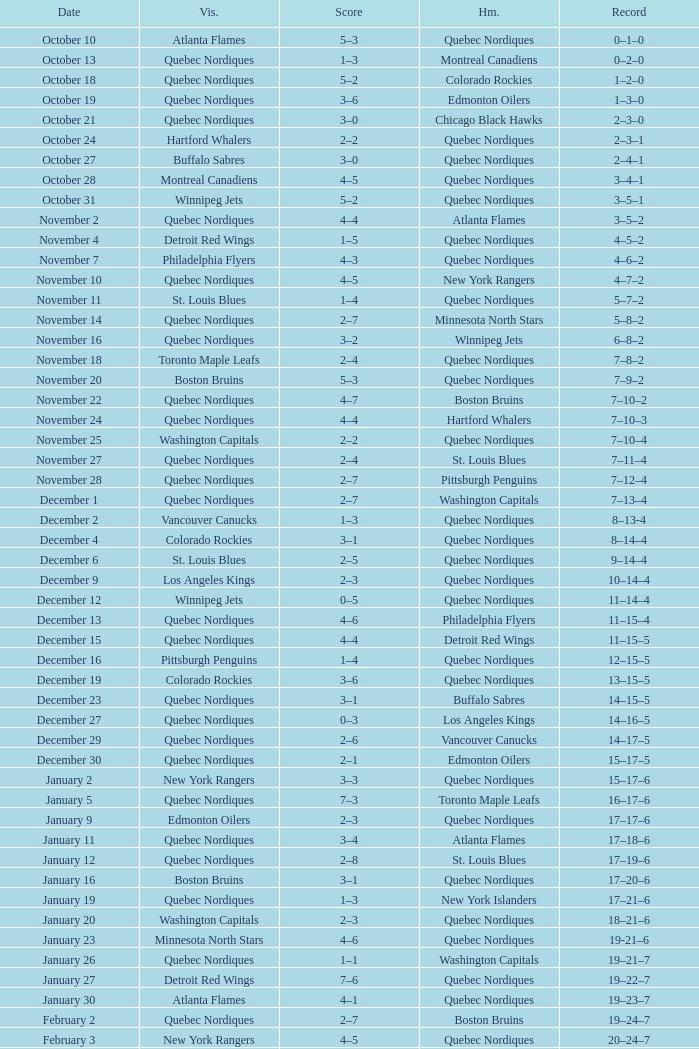Would you mind parsing the complete table? {'header': ['Date', 'Vis.', 'Score', 'Hm.', 'Record'], 'rows': [['October 10', 'Atlanta Flames', '5–3', 'Quebec Nordiques', '0–1–0'], ['October 13', 'Quebec Nordiques', '1–3', 'Montreal Canadiens', '0–2–0'], ['October 18', 'Quebec Nordiques', '5–2', 'Colorado Rockies', '1–2–0'], ['October 19', 'Quebec Nordiques', '3–6', 'Edmonton Oilers', '1–3–0'], ['October 21', 'Quebec Nordiques', '3–0', 'Chicago Black Hawks', '2–3–0'], ['October 24', 'Hartford Whalers', '2–2', 'Quebec Nordiques', '2–3–1'], ['October 27', 'Buffalo Sabres', '3–0', 'Quebec Nordiques', '2–4–1'], ['October 28', 'Montreal Canadiens', '4–5', 'Quebec Nordiques', '3–4–1'], ['October 31', 'Winnipeg Jets', '5–2', 'Quebec Nordiques', '3–5–1'], ['November 2', 'Quebec Nordiques', '4–4', 'Atlanta Flames', '3–5–2'], ['November 4', 'Detroit Red Wings', '1–5', 'Quebec Nordiques', '4–5–2'], ['November 7', 'Philadelphia Flyers', '4–3', 'Quebec Nordiques', '4–6–2'], ['November 10', 'Quebec Nordiques', '4–5', 'New York Rangers', '4–7–2'], ['November 11', 'St. Louis Blues', '1–4', 'Quebec Nordiques', '5–7–2'], ['November 14', 'Quebec Nordiques', '2–7', 'Minnesota North Stars', '5–8–2'], ['November 16', 'Quebec Nordiques', '3–2', 'Winnipeg Jets', '6–8–2'], ['November 18', 'Toronto Maple Leafs', '2–4', 'Quebec Nordiques', '7–8–2'], ['November 20', 'Boston Bruins', '5–3', 'Quebec Nordiques', '7–9–2'], ['November 22', 'Quebec Nordiques', '4–7', 'Boston Bruins', '7–10–2'], ['November 24', 'Quebec Nordiques', '4–4', 'Hartford Whalers', '7–10–3'], ['November 25', 'Washington Capitals', '2–2', 'Quebec Nordiques', '7–10–4'], ['November 27', 'Quebec Nordiques', '2–4', 'St. Louis Blues', '7–11–4'], ['November 28', 'Quebec Nordiques', '2–7', 'Pittsburgh Penguins', '7–12–4'], ['December 1', 'Quebec Nordiques', '2–7', 'Washington Capitals', '7–13–4'], ['December 2', 'Vancouver Canucks', '1–3', 'Quebec Nordiques', '8–13-4'], ['December 4', 'Colorado Rockies', '3–1', 'Quebec Nordiques', '8–14–4'], ['December 6', 'St. Louis Blues', '2–5', 'Quebec Nordiques', '9–14–4'], ['December 9', 'Los Angeles Kings', '2–3', 'Quebec Nordiques', '10–14–4'], ['December 12', 'Winnipeg Jets', '0–5', 'Quebec Nordiques', '11–14–4'], ['December 13', 'Quebec Nordiques', '4–6', 'Philadelphia Flyers', '11–15–4'], ['December 15', 'Quebec Nordiques', '4–4', 'Detroit Red Wings', '11–15–5'], ['December 16', 'Pittsburgh Penguins', '1–4', 'Quebec Nordiques', '12–15–5'], ['December 19', 'Colorado Rockies', '3–6', 'Quebec Nordiques', '13–15–5'], ['December 23', 'Quebec Nordiques', '3–1', 'Buffalo Sabres', '14–15–5'], ['December 27', 'Quebec Nordiques', '0–3', 'Los Angeles Kings', '14–16–5'], ['December 29', 'Quebec Nordiques', '2–6', 'Vancouver Canucks', '14–17–5'], ['December 30', 'Quebec Nordiques', '2–1', 'Edmonton Oilers', '15–17–5'], ['January 2', 'New York Rangers', '3–3', 'Quebec Nordiques', '15–17–6'], ['January 5', 'Quebec Nordiques', '7–3', 'Toronto Maple Leafs', '16–17–6'], ['January 9', 'Edmonton Oilers', '2–3', 'Quebec Nordiques', '17–17–6'], ['January 11', 'Quebec Nordiques', '3–4', 'Atlanta Flames', '17–18–6'], ['January 12', 'Quebec Nordiques', '2–8', 'St. Louis Blues', '17–19–6'], ['January 16', 'Boston Bruins', '3–1', 'Quebec Nordiques', '17–20–6'], ['January 19', 'Quebec Nordiques', '1–3', 'New York Islanders', '17–21–6'], ['January 20', 'Washington Capitals', '2–3', 'Quebec Nordiques', '18–21–6'], ['January 23', 'Minnesota North Stars', '4–6', 'Quebec Nordiques', '19-21–6'], ['January 26', 'Quebec Nordiques', '1–1', 'Washington Capitals', '19–21–7'], ['January 27', 'Detroit Red Wings', '7–6', 'Quebec Nordiques', '19–22–7'], ['January 30', 'Atlanta Flames', '4–1', 'Quebec Nordiques', '19–23–7'], ['February 2', 'Quebec Nordiques', '2–7', 'Boston Bruins', '19–24–7'], ['February 3', 'New York Rangers', '4–5', 'Quebec Nordiques', '20–24–7'], ['February 6', 'Chicago Black Hawks', '3–3', 'Quebec Nordiques', '20–24–8'], ['February 9', 'Quebec Nordiques', '0–5', 'New York Islanders', '20–25–8'], ['February 10', 'Quebec Nordiques', '1–3', 'New York Rangers', '20–26–8'], ['February 14', 'Quebec Nordiques', '1–5', 'Montreal Canadiens', '20–27–8'], ['February 17', 'Quebec Nordiques', '5–6', 'Winnipeg Jets', '20–28–8'], ['February 18', 'Quebec Nordiques', '2–6', 'Minnesota North Stars', '20–29–8'], ['February 19', 'Buffalo Sabres', '3–1', 'Quebec Nordiques', '20–30–8'], ['February 23', 'Quebec Nordiques', '1–2', 'Pittsburgh Penguins', '20–31–8'], ['February 24', 'Pittsburgh Penguins', '0–2', 'Quebec Nordiques', '21–31–8'], ['February 26', 'Hartford Whalers', '5–9', 'Quebec Nordiques', '22–31–8'], ['February 27', 'New York Islanders', '5–3', 'Quebec Nordiques', '22–32–8'], ['March 2', 'Los Angeles Kings', '4–3', 'Quebec Nordiques', '22–33–8'], ['March 5', 'Minnesota North Stars', '3-3', 'Quebec Nordiques', '22–33–9'], ['March 8', 'Quebec Nordiques', '2–3', 'Toronto Maple Leafs', '22–34–9'], ['March 9', 'Toronto Maple Leafs', '4–5', 'Quebec Nordiques', '23–34-9'], ['March 12', 'Edmonton Oilers', '6–3', 'Quebec Nordiques', '23–35–9'], ['March 16', 'Vancouver Canucks', '3–2', 'Quebec Nordiques', '23–36–9'], ['March 19', 'Quebec Nordiques', '2–5', 'Chicago Black Hawks', '23–37–9'], ['March 20', 'Quebec Nordiques', '6–2', 'Colorado Rockies', '24–37–9'], ['March 22', 'Quebec Nordiques', '1-4', 'Los Angeles Kings', '24–38-9'], ['March 23', 'Quebec Nordiques', '6–2', 'Vancouver Canucks', '25–38–9'], ['March 26', 'Chicago Black Hawks', '7–2', 'Quebec Nordiques', '25–39–9'], ['March 27', 'Quebec Nordiques', '2–5', 'Philadelphia Flyers', '25–40–9'], ['March 29', 'Quebec Nordiques', '7–9', 'Detroit Red Wings', '25–41–9'], ['March 30', 'New York Islanders', '9–6', 'Quebec Nordiques', '25–42–9'], ['April 1', 'Philadelphia Flyers', '3–3', 'Quebec Nordiques', '25–42–10'], ['April 3', 'Quebec Nordiques', '3–8', 'Buffalo Sabres', '25–43–10'], ['April 4', 'Quebec Nordiques', '2–9', 'Hartford Whalers', '25–44–10'], ['April 6', 'Montreal Canadiens', '4–4', 'Quebec Nordiques', '25–44–11']]} Which Record has a Score of 2–4, and a Home of quebec nordiques? 7–8–2. 